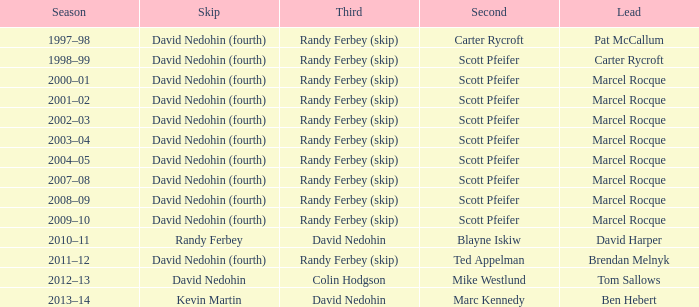Which skip is associated with the 2002-03 season? David Nedohin (fourth). 